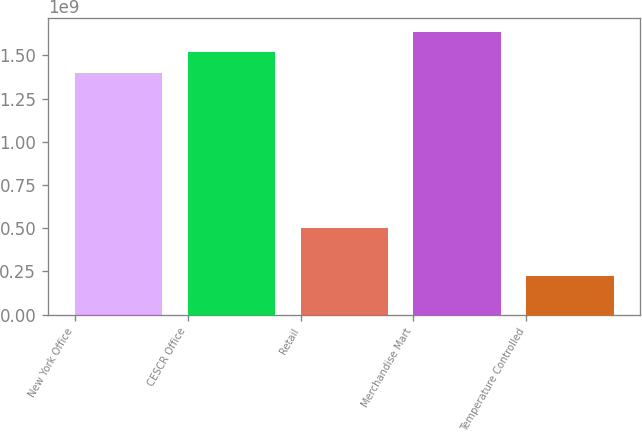<chart> <loc_0><loc_0><loc_500><loc_500><bar_chart><fcel>New York Office<fcel>CESCR Office<fcel>Retail<fcel>Merchandise Mart<fcel>Temperature Controlled<nl><fcel>1.4e+09<fcel>1.5175e+09<fcel>5e+08<fcel>1.635e+09<fcel>2.25e+08<nl></chart> 